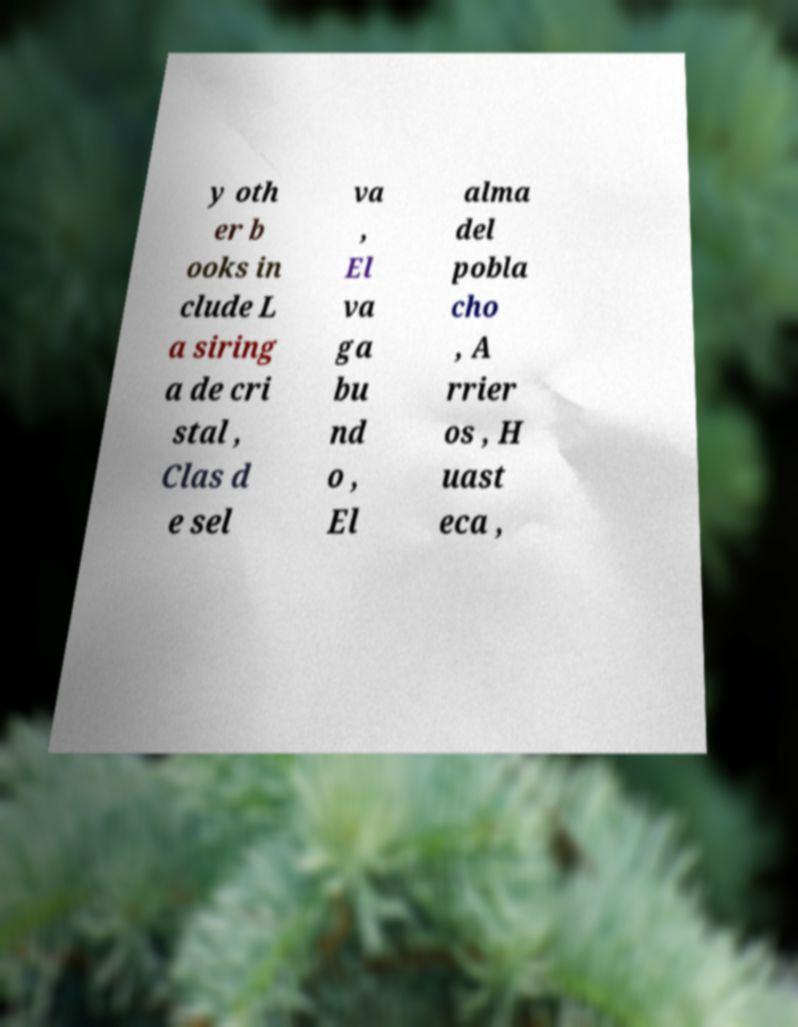There's text embedded in this image that I need extracted. Can you transcribe it verbatim? y oth er b ooks in clude L a siring a de cri stal , Clas d e sel va , El va ga bu nd o , El alma del pobla cho , A rrier os , H uast eca , 